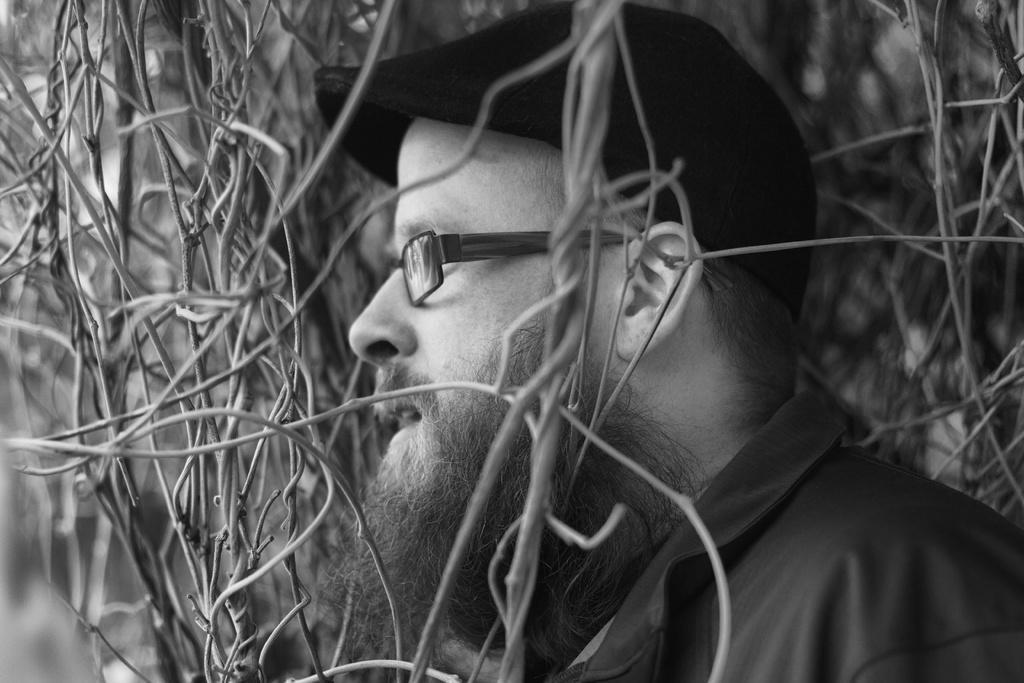Describe this image in one or two sentences. This is black and white picture,there is a man wore spectacle and we can see twigs. 